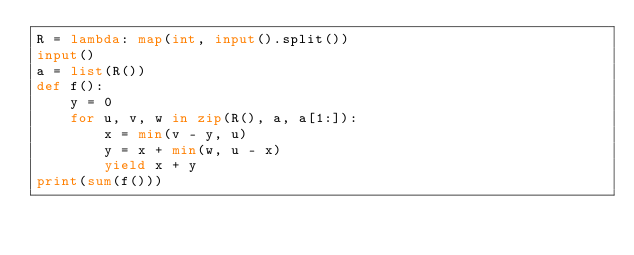Convert code to text. <code><loc_0><loc_0><loc_500><loc_500><_Python_>R = lambda: map(int, input().split())
input()
a = list(R())
def f():
    y = 0
    for u, v, w in zip(R(), a, a[1:]):
        x = min(v - y, u)
        y = x + min(w, u - x)
        yield x + y
print(sum(f()))
</code> 